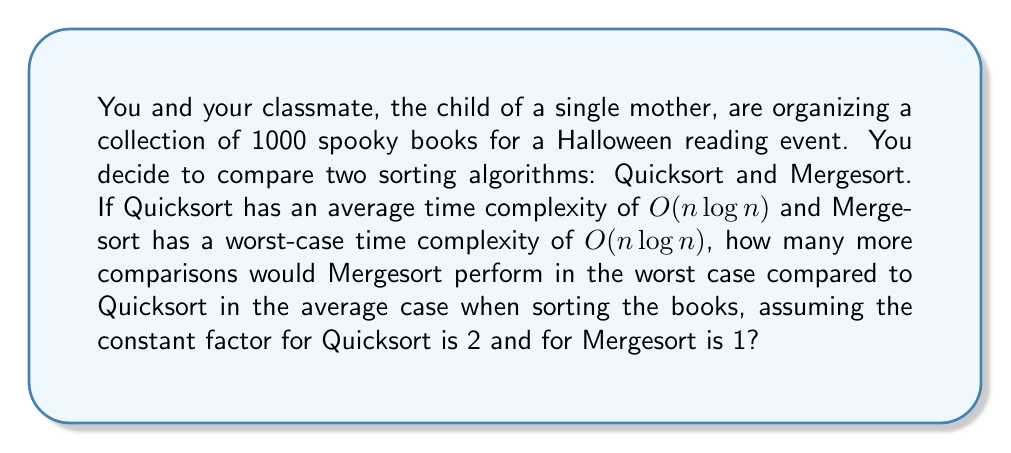Can you answer this question? Let's approach this step-by-step:

1) First, we need to calculate the number of comparisons for Quicksort in the average case:
   
   Quicksort: $T_Q(n) = 2n \log_2 n$
   
   For $n = 1000$:
   $T_Q(1000) = 2 * 1000 * \log_2 1000 = 2000 * \log_2 1000 \approx 19931.57$

2) Now, let's calculate the number of comparisons for Mergesort in the worst case:
   
   Mergesort: $T_M(n) = n \log_2 n$
   
   For $n = 1000$:
   $T_M(1000) = 1000 * \log_2 1000 = 1000 * \log_2 1000 \approx 9965.78$

3) To find how many more comparisons Mergesort would perform, we subtract:

   $T_Q(1000) - T_M(1000) = 19931.57 - 9965.78 \approx 9965.79$

4) However, the question asks for how many more comparisons Mergesort would perform compared to Quicksort, so we need to reverse this:

   $T_M(1000) - T_Q(1000) = 9965.78 - 19931.57 \approx -9965.79$

5) The negative sign indicates that Mergesort actually performs fewer comparisons in this case.
Answer: Mergesort would perform approximately 9966 fewer comparisons than Quicksort under these conditions. 